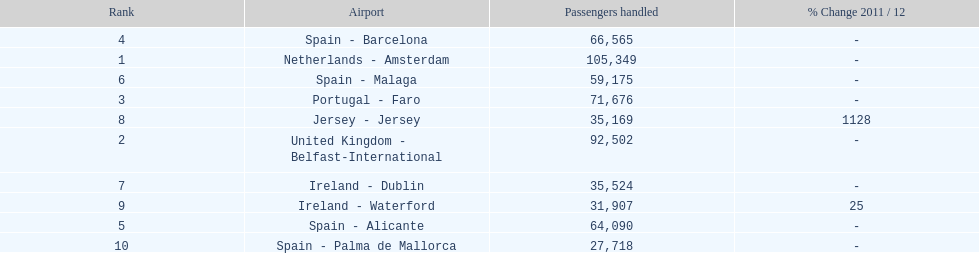Which airport had more passengers handled than the united kingdom? Netherlands - Amsterdam. 